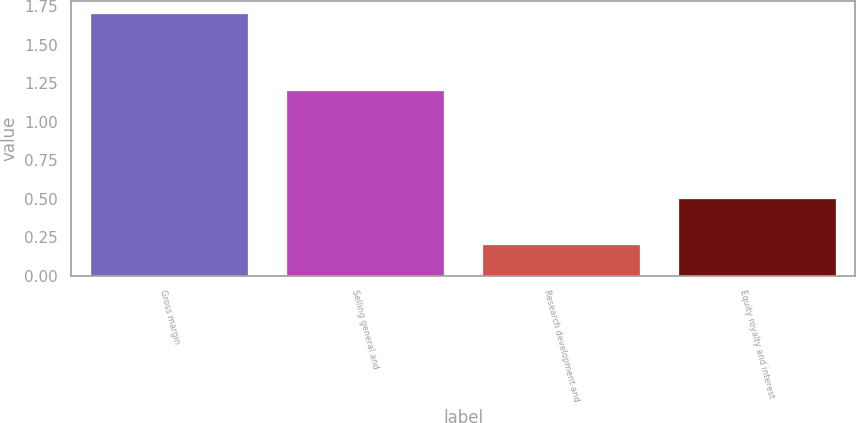<chart> <loc_0><loc_0><loc_500><loc_500><bar_chart><fcel>Gross margin<fcel>Selling general and<fcel>Research development and<fcel>Equity royalty and interest<nl><fcel>1.7<fcel>1.2<fcel>0.2<fcel>0.5<nl></chart> 